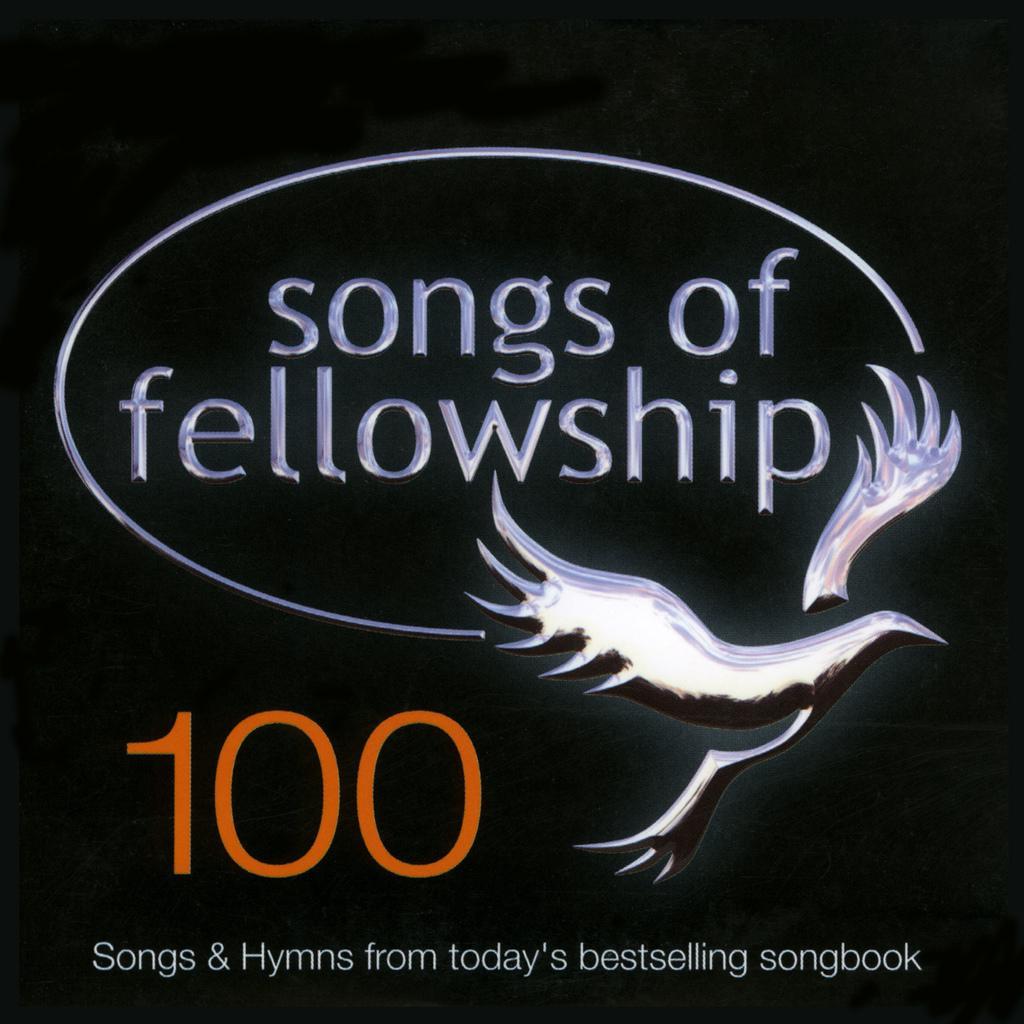Please provide a concise description of this image. In this picture there is songs of fellowship is written on it and there is something written below it. 